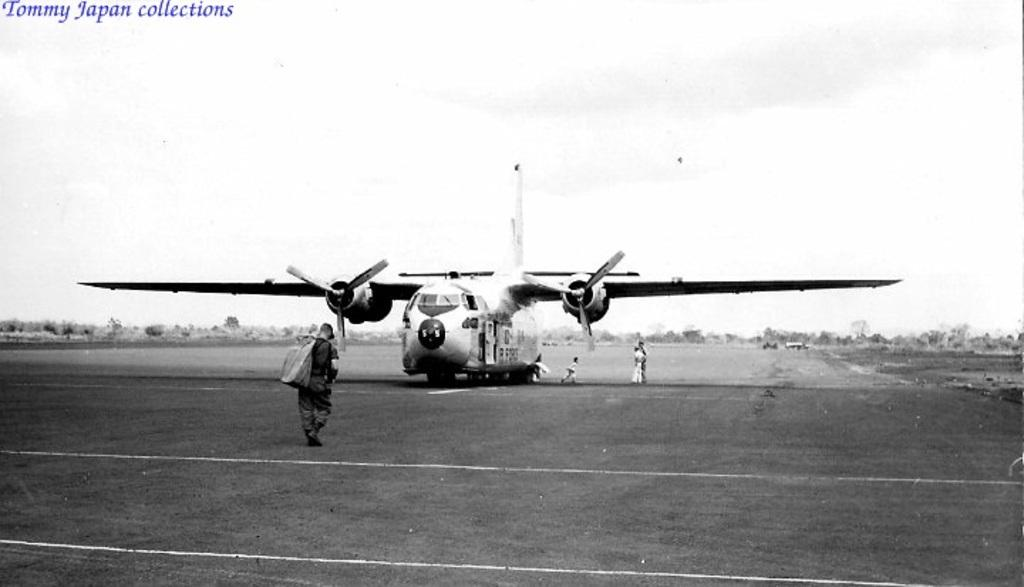How many persons are in the image? There are persons in the image. What is the main subject in the image besides the persons? There is an aircraft in the image. What can be seen in the background of the image? There are trees and the sky visible in the background of the image. What is the color scheme of the image? The image is in black and white. Can you hear the whistle of the pie in the image? There is no whistle or pie present in the image. 